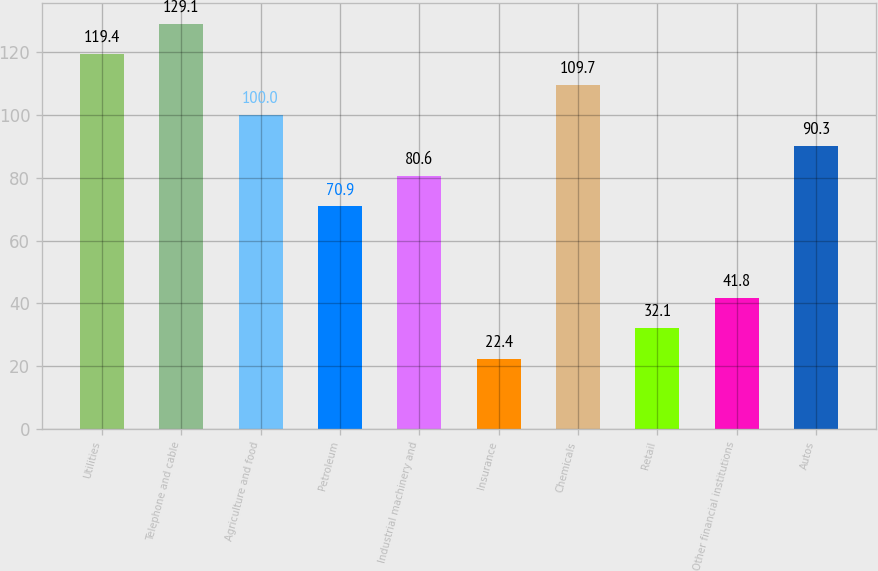Convert chart to OTSL. <chart><loc_0><loc_0><loc_500><loc_500><bar_chart><fcel>Utilities<fcel>Telephone and cable<fcel>Agriculture and food<fcel>Petroleum<fcel>Industrial machinery and<fcel>Insurance<fcel>Chemicals<fcel>Retail<fcel>Other financial institutions<fcel>Autos<nl><fcel>119.4<fcel>129.1<fcel>100<fcel>70.9<fcel>80.6<fcel>22.4<fcel>109.7<fcel>32.1<fcel>41.8<fcel>90.3<nl></chart> 